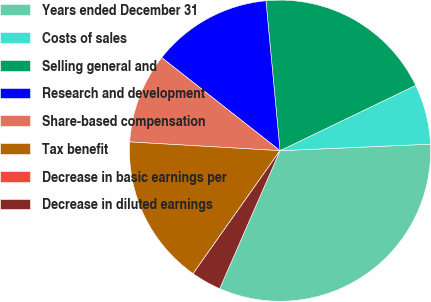<chart> <loc_0><loc_0><loc_500><loc_500><pie_chart><fcel>Years ended December 31<fcel>Costs of sales<fcel>Selling general and<fcel>Research and development<fcel>Share-based compensation<fcel>Tax benefit<fcel>Decrease in basic earnings per<fcel>Decrease in diluted earnings<nl><fcel>32.25%<fcel>6.45%<fcel>19.35%<fcel>12.9%<fcel>9.68%<fcel>16.13%<fcel>0.0%<fcel>3.23%<nl></chart> 